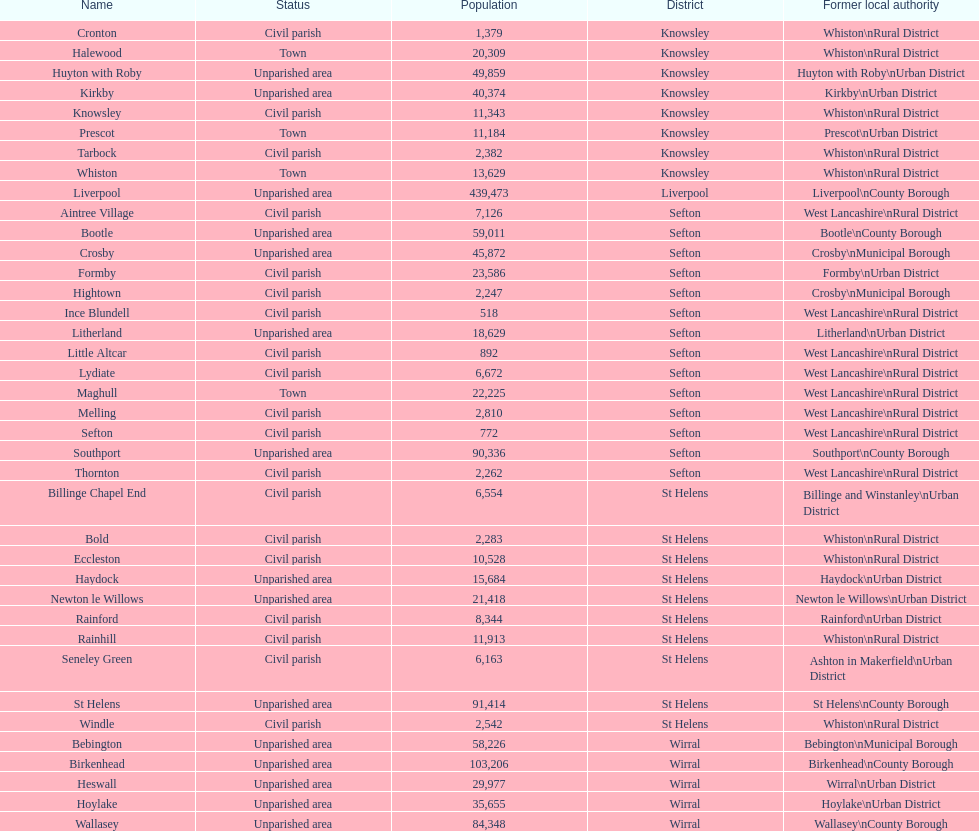Which area has the largest population? Liverpool. 